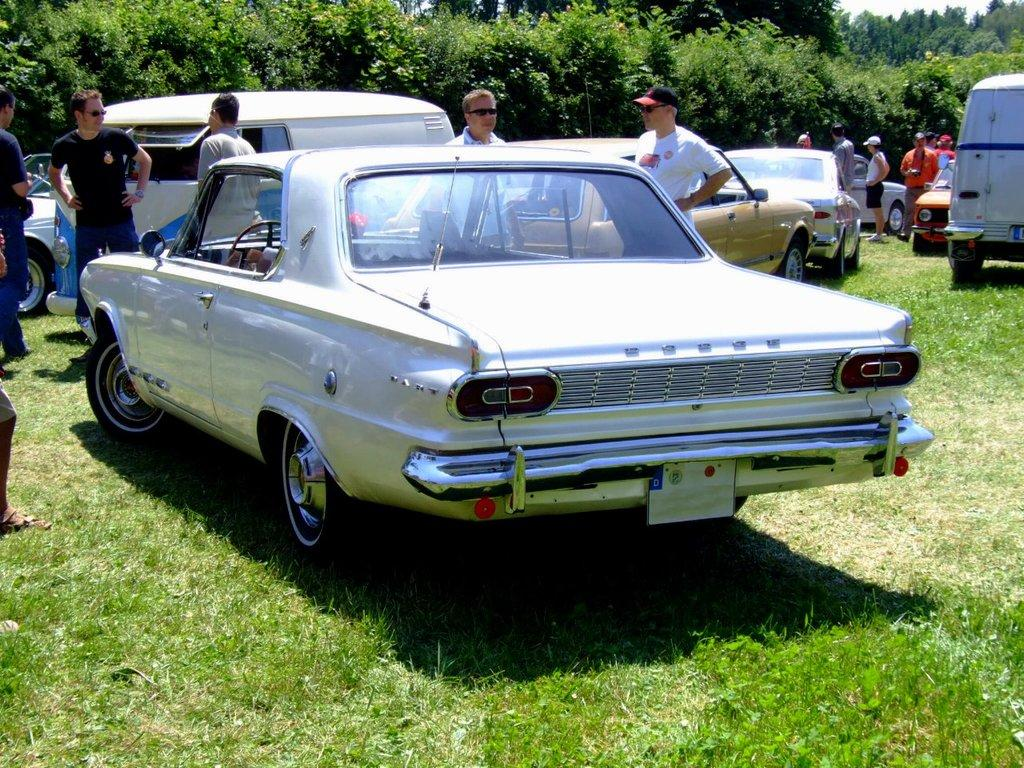What type of vehicles can be seen in the image? There are cars in the image. What are the people in the image doing? The people are standing on the grass. What can be seen in the background of the image? There are trees and the sky visible in the background of the image. How many tigers are present in the image? There are no tigers present in the image. What type of flock can be seen flying in the sky in the image? There is no flock visible in the sky in the image. 